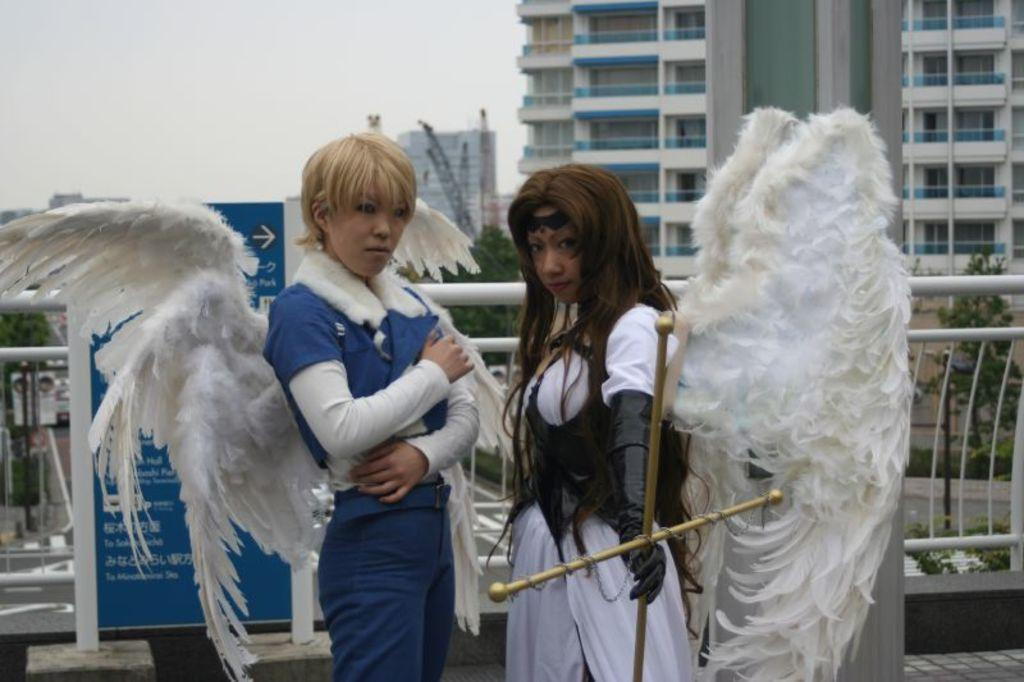How many people are in the image? There are two people in the image. What is unique about the appearance of these people? The two people have wings. What is one of the people doing with their hands? One of the people is holding an object. What can be seen in the background of the image? There are trees, a hoarding, and buildings in the background of the image. What is the rate of the shade provided by the trees in the image? There is no information about the rate of shade provided by the trees in the image. Can you tell me what request the people in the image are making? There is no indication of a request being made by the people in the image. 